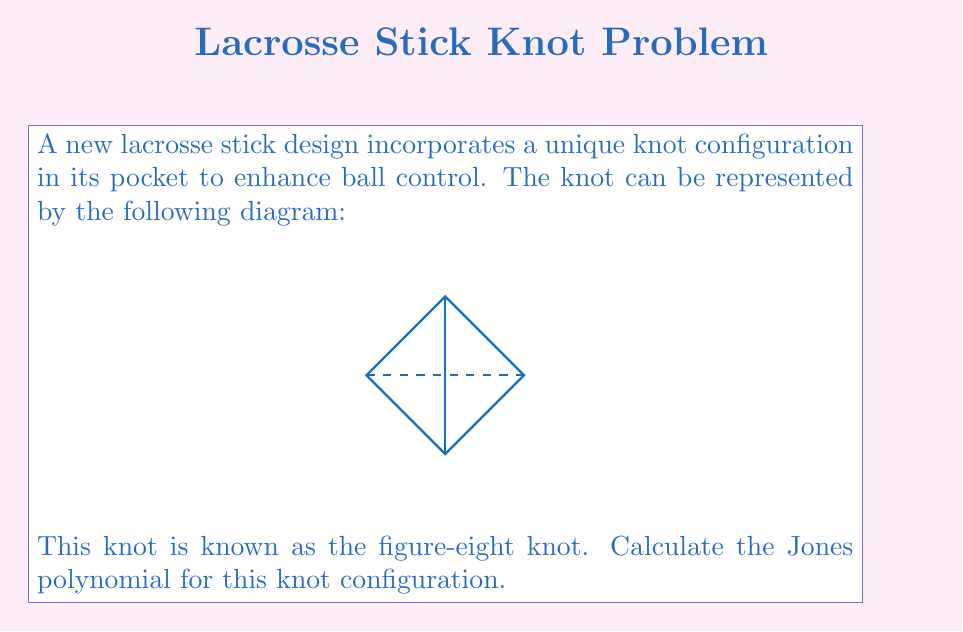Show me your answer to this math problem. To calculate the Jones polynomial for the figure-eight knot, we'll follow these steps:

1) First, we need to create an oriented diagram of the knot. The figure-eight knot has 4 crossings.

2) We'll use the skein relation for the Jones polynomial:
   $$t^{-1}V(L_+) - tV(L_-) = (t^{1/2} - t^{-1/2})V(L_0)$$
   where $L_+$, $L_-$, and $L_0$ represent positive crossing, negative crossing, and smoothed crossing respectively.

3) For the figure-eight knot, we can smooth one crossing to get two unlinked trefoil knots. The Jones polynomial for a trefoil knot is:
   $$V(\text{trefoil}) = t + t^3 - t^4$$

4) Let $V(8)$ be the Jones polynomial of the figure-eight knot. Applying the skein relation:
   $$t^{-1}V(8) - tV(\text{unknot}) = (t^{1/2} - t^{-1/2})V(\text{two trefoils})$$

5) We know that $V(\text{unknot}) = 1$ and $V(\text{two trefoils}) = (t + t^3 - t^4)^2$

6) Substituting these values:
   $$t^{-1}V(8) - t = (t^{1/2} - t^{-1/2})(t + t^3 - t^4)^2$$

7) Multiply both sides by $t$:
   $$V(8) - t^2 = (t^{3/2} - t^{1/2})(t + t^3 - t^4)^2$$

8) Expand the right side and solve for $V(8)$:
   $$V(8) = t^2 + (t^{3/2} - t^{1/2})(t + t^3 - t^4)^2$$

9) Simplify:
   $$V(8) = t^2 + (t^{3/2} - t^{1/2})(t^2 + 2t^4 - 2t^5 + t^6 - 2t^7 + t^8)$$
   $$V(8) = t^2 + t^{7/2} + 2t^{11/2} - 2t^{13/2} + t^{15/2} - 2t^{17/2} + t^{19/2} - t^{5/2} - 2t^{9/2} + 2t^{11/2} - t^{13/2} + 2t^{15/2} - t^{17/2}$$

10) Collecting like terms:
    $$V(8) = t^{-2} - t^{-1} + 1 - t + t^2$$
Answer: $t^{-2} - t^{-1} + 1 - t + t^2$ 